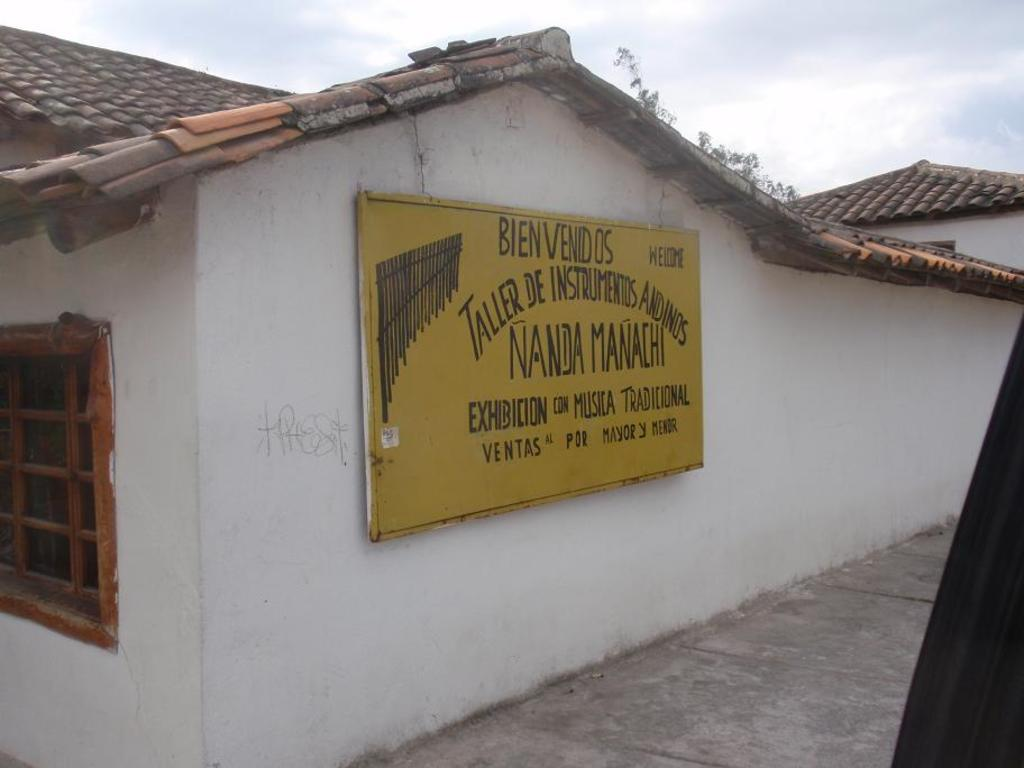What type of structure is visible in the image? There is a building in the image. What is written or displayed on the wall of the building? There is a board with text on the wall. Can you describe any openings in the building? There is a window in the image. What can be seen in the background of the image? The sky is visible in the background of the image, and there are clouds in the sky. What type of owl can be seen perched on the window sill in the image? There is no owl present in the image; it only features a building, a board with text, a window, and a sky with clouds. 